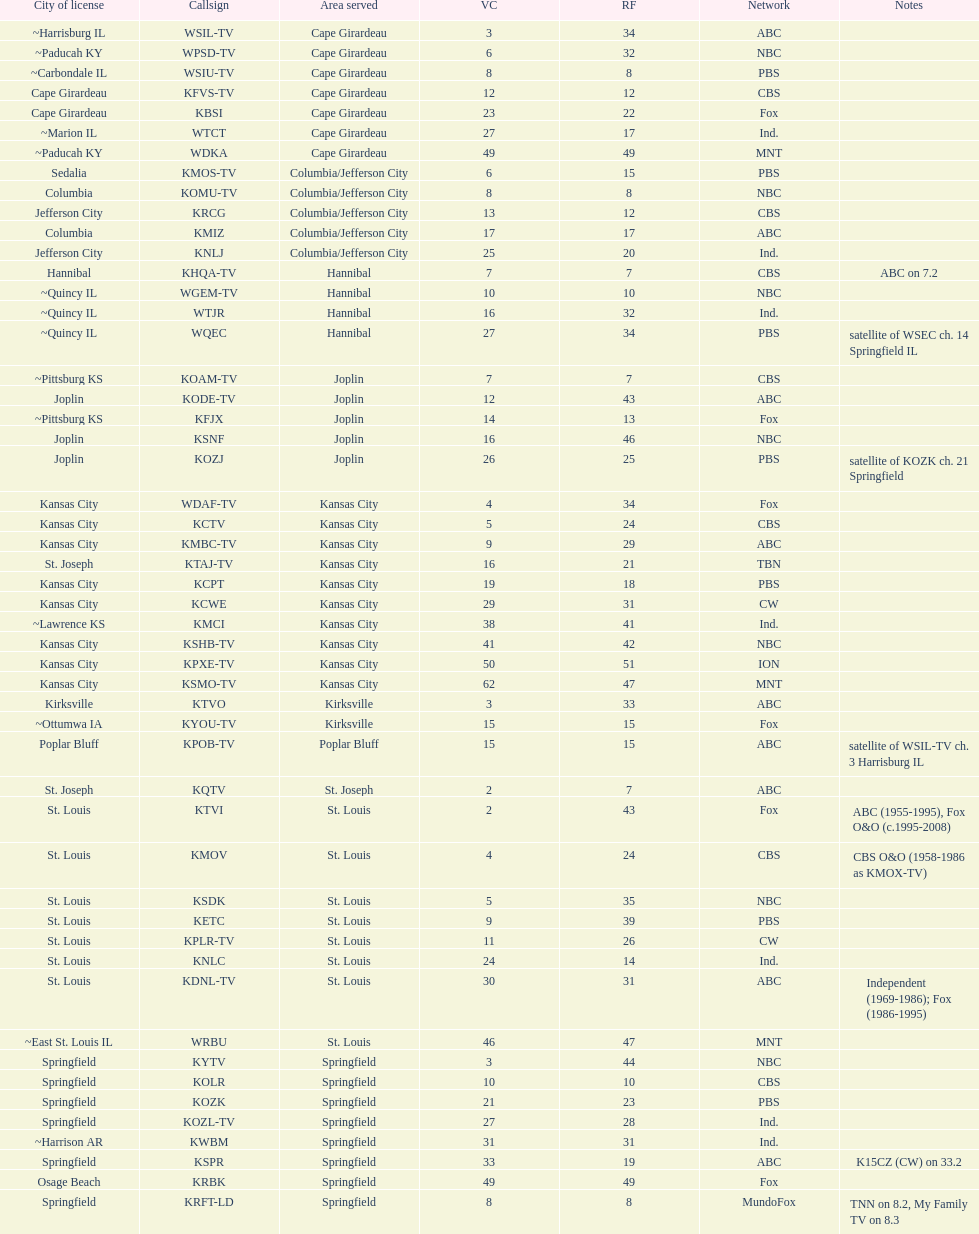How many of these missouri tv stations are actually licensed in a city in illinois (il)? 7. 